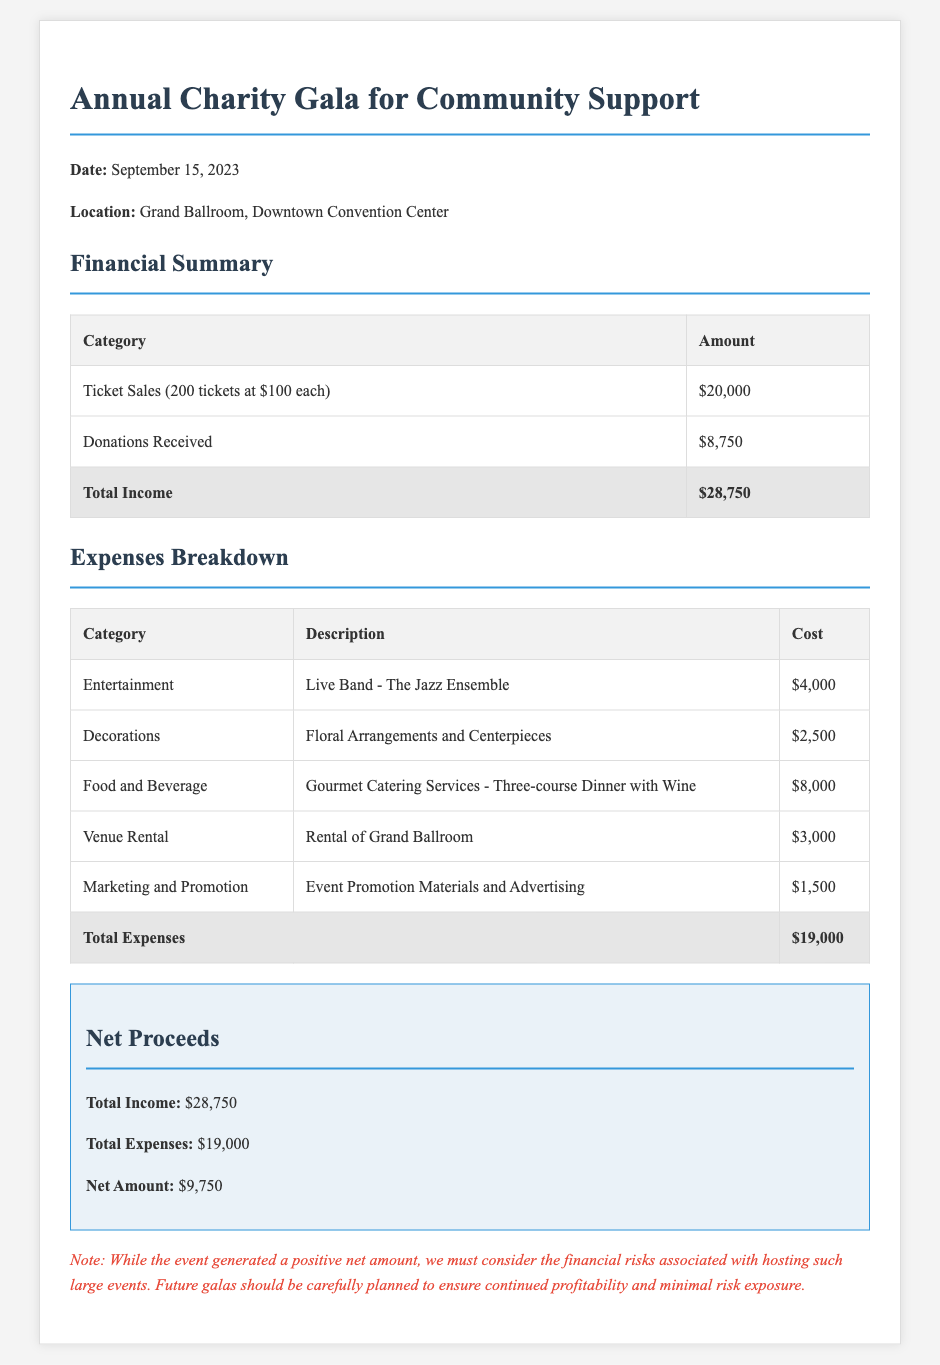What is the date of the gala? The date of the gala is explicitly mentioned in the document as September 15, 2023.
Answer: September 15, 2023 What were the total ticket sales? The total ticket sales amount is calculated based on the number of tickets sold at a specified price, resulting in $20,000 for this event.
Answer: $20,000 How much was received in donations? The document states that the donations received totaled $8,750.
Answer: $8,750 What was the cost of the live band's performance? The cost associated with hiring the live band, as listed in the document, is $4,000.
Answer: $4,000 What is the total amount of net proceeds? The net amount is derived from the subtraction of total expenses from total income, which results in $9,750.
Answer: $9,750 How much was spent on decorations? The specific cost for decorations, which includes floral arrangements and centerpieces, is mentioned as $2,500.
Answer: $2,500 What is the total expenses amount? The total expenses, as summarized in the document, amount to $19,000.
Answer: $19,000 Which category had the highest expense? The category with the highest expense is food and beverage, amounting to $8,000.
Answer: Food and Beverage What is a significant financial warning noted in the document? The document warns about the financial risks associated with hosting large events, advising for careful future planning to ensure profitability.
Answer: Financial risks 